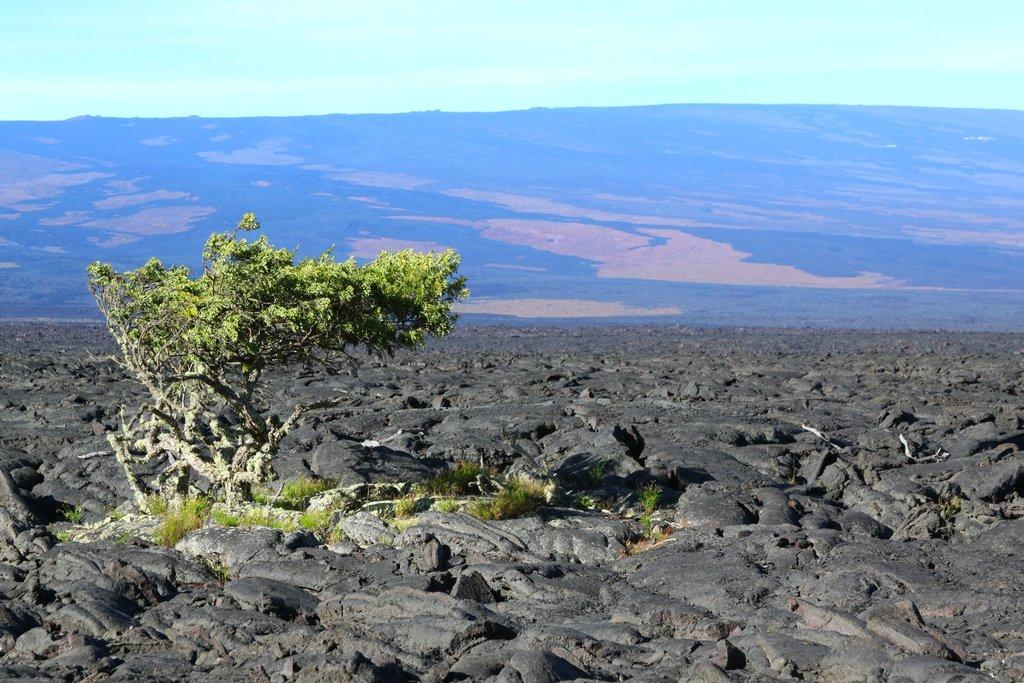What is present at the bottom of the image? There are rocks, trees, and grass at the bottom of the image. What can be seen in the background of the image? There is a mountain in the background of the image, and there are clouds in the sky. Where is the group of coal miners working in the image? There is no group of coal miners present in the image. The image features rocks, trees, grass, a mountain, and clouds in the sky. 